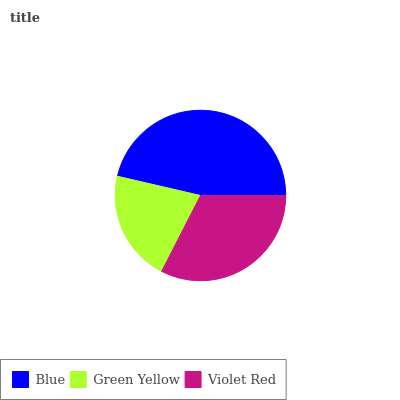Is Green Yellow the minimum?
Answer yes or no. Yes. Is Blue the maximum?
Answer yes or no. Yes. Is Violet Red the minimum?
Answer yes or no. No. Is Violet Red the maximum?
Answer yes or no. No. Is Violet Red greater than Green Yellow?
Answer yes or no. Yes. Is Green Yellow less than Violet Red?
Answer yes or no. Yes. Is Green Yellow greater than Violet Red?
Answer yes or no. No. Is Violet Red less than Green Yellow?
Answer yes or no. No. Is Violet Red the high median?
Answer yes or no. Yes. Is Violet Red the low median?
Answer yes or no. Yes. Is Green Yellow the high median?
Answer yes or no. No. Is Green Yellow the low median?
Answer yes or no. No. 